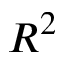<formula> <loc_0><loc_0><loc_500><loc_500>R ^ { 2 }</formula> 